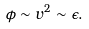Convert formula to latex. <formula><loc_0><loc_0><loc_500><loc_500>\phi \sim v ^ { 2 } \sim \epsilon .</formula> 